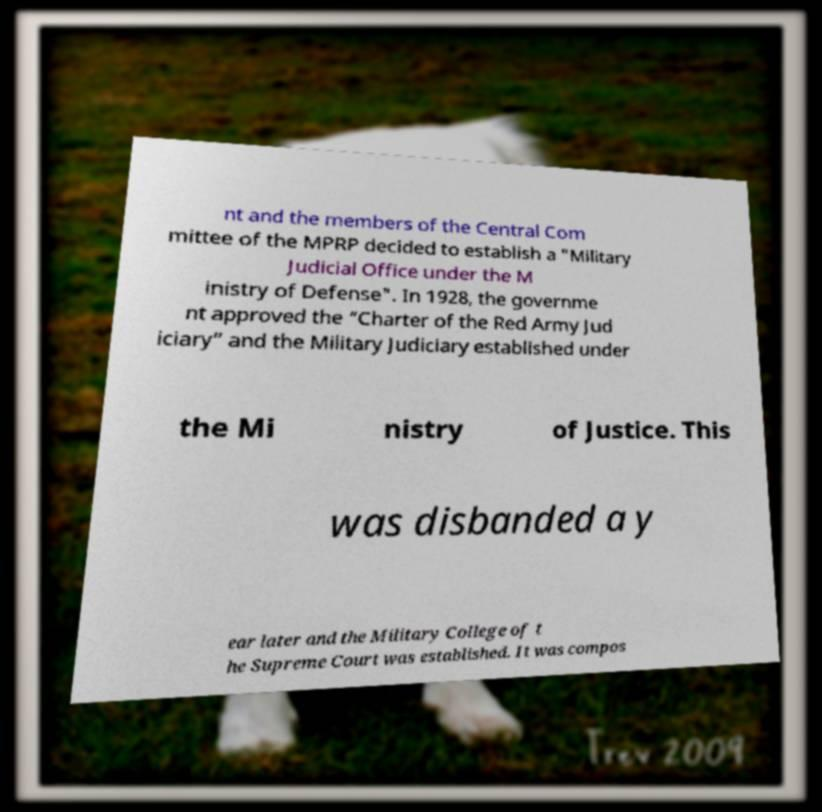I need the written content from this picture converted into text. Can you do that? nt and the members of the Central Com mittee of the MPRP decided to establish a "Military Judicial Office under the M inistry of Defense". In 1928, the governme nt approved the “Charter of the Red Army Jud iciary” and the Military Judiciary established under the Mi nistry of Justice. This was disbanded a y ear later and the Military College of t he Supreme Court was established. It was compos 